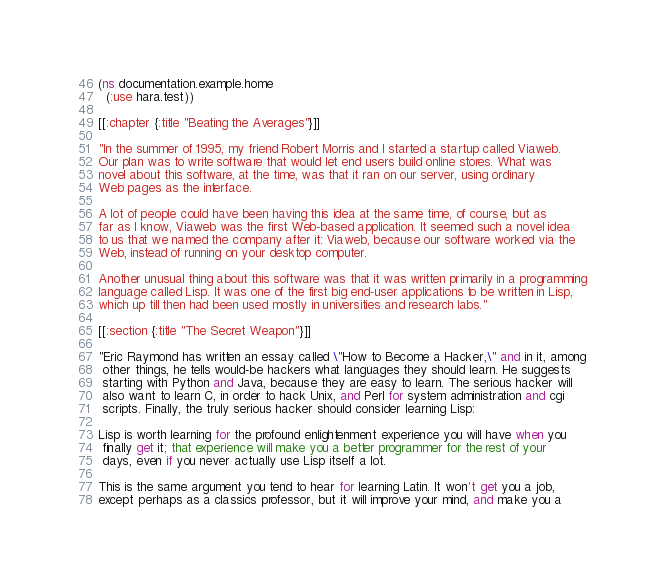Convert code to text. <code><loc_0><loc_0><loc_500><loc_500><_Clojure_>(ns documentation.example.home
  (:use hara.test))

[[:chapter {:title "Beating the Averages"}]]

"In the summer of 1995, my friend Robert Morris and I started a startup called Viaweb.
Our plan was to write software that would let end users build online stores. What was
novel about this software, at the time, was that it ran on our server, using ordinary
Web pages as the interface.

A lot of people could have been having this idea at the same time, of course, but as
far as I know, Viaweb was the first Web-based application. It seemed such a novel idea
to us that we named the company after it: Viaweb, because our software worked via the
Web, instead of running on your desktop computer.

Another unusual thing about this software was that it was written primarily in a programming
language called Lisp. It was one of the first big end-user applications to be written in Lisp,
which up till then had been used mostly in universities and research labs."

[[:section {:title "The Secret Weapon"}]]

"Eric Raymond has written an essay called \"How to Become a Hacker,\" and in it, among
 other things, he tells would-be hackers what languages they should learn. He suggests
 starting with Python and Java, because they are easy to learn. The serious hacker will
 also want to learn C, in order to hack Unix, and Perl for system administration and cgi
 scripts. Finally, the truly serious hacker should consider learning Lisp:

Lisp is worth learning for the profound enlightenment experience you will have when you
 finally get it; that experience will make you a better programmer for the rest of your
 days, even if you never actually use Lisp itself a lot.

This is the same argument you tend to hear for learning Latin. It won't get you a job,
except perhaps as a classics professor, but it will improve your mind, and make you a</code> 